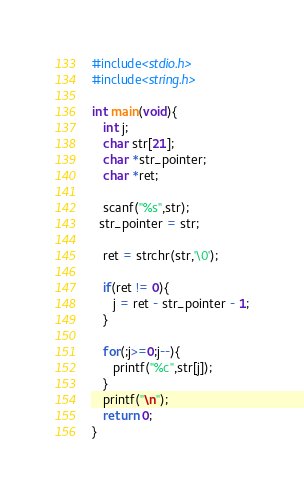<code> <loc_0><loc_0><loc_500><loc_500><_C_>#include<stdio.h>
#include<string.h>

int main(void){
   int j;
   char str[21];
   char *str_pointer;
   char *ret;
   
   scanf("%s",str);
  str_pointer = str;
   
   ret = strchr(str,'\0');
   
   if(ret != 0){
      j = ret - str_pointer - 1;
   }
   
   for(;j>=0;j--){
      printf("%c",str[j]);
   }
   printf("\n");
   return 0;
}</code> 